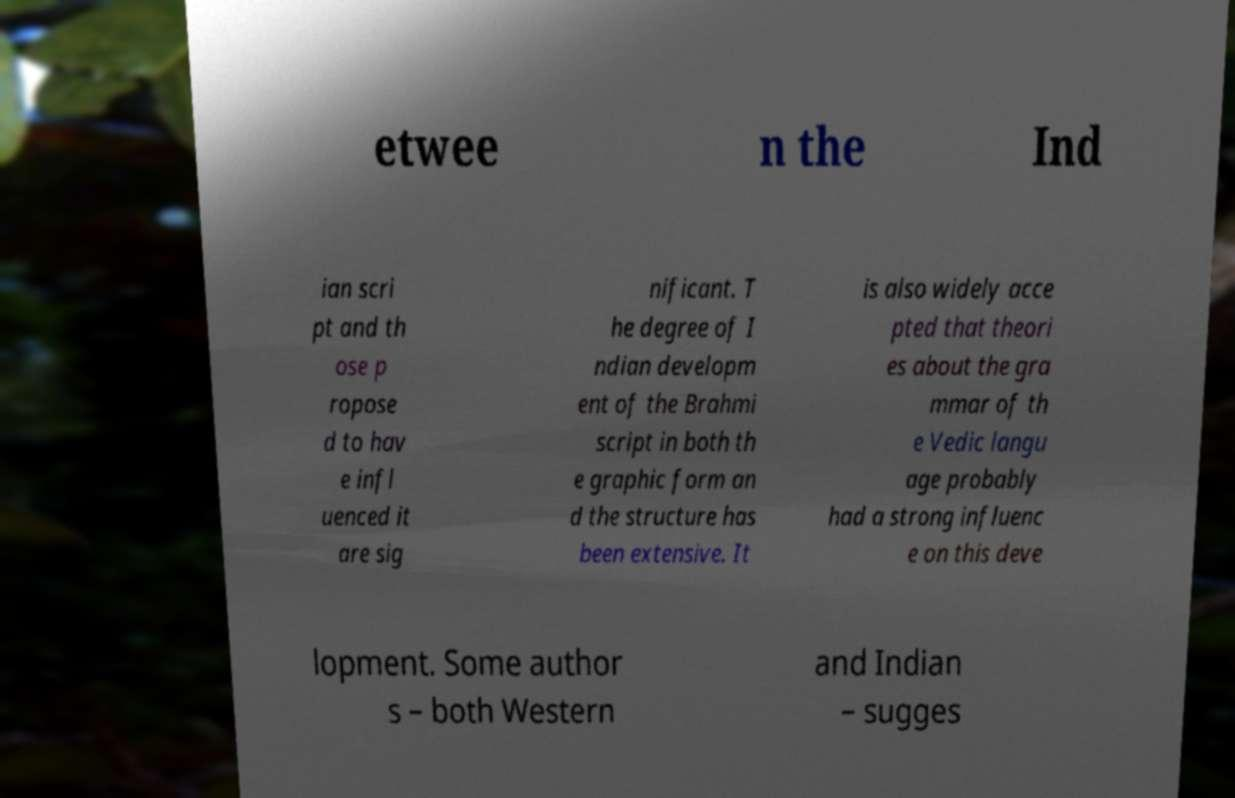I need the written content from this picture converted into text. Can you do that? etwee n the Ind ian scri pt and th ose p ropose d to hav e infl uenced it are sig nificant. T he degree of I ndian developm ent of the Brahmi script in both th e graphic form an d the structure has been extensive. It is also widely acce pted that theori es about the gra mmar of th e Vedic langu age probably had a strong influenc e on this deve lopment. Some author s – both Western and Indian – sugges 